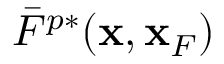<formula> <loc_0><loc_0><loc_500><loc_500>\bar { F } ^ { p * } ( { x } , { x } _ { F } )</formula> 